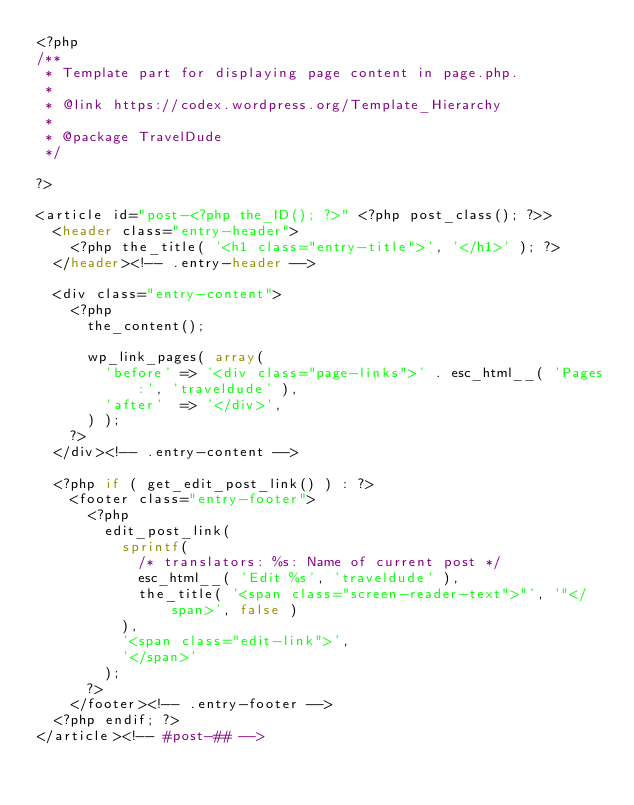<code> <loc_0><loc_0><loc_500><loc_500><_PHP_><?php
/**
 * Template part for displaying page content in page.php.
 *
 * @link https://codex.wordpress.org/Template_Hierarchy
 *
 * @package TravelDude
 */

?>

<article id="post-<?php the_ID(); ?>" <?php post_class(); ?>>
	<header class="entry-header">
		<?php the_title( '<h1 class="entry-title">', '</h1>' ); ?>
	</header><!-- .entry-header -->

	<div class="entry-content">
		<?php
			the_content();

			wp_link_pages( array(
				'before' => '<div class="page-links">' . esc_html__( 'Pages:', 'traveldude' ),
				'after'  => '</div>',
			) );
		?>
	</div><!-- .entry-content -->

	<?php if ( get_edit_post_link() ) : ?>
		<footer class="entry-footer">
			<?php
				edit_post_link(
					sprintf(
						/* translators: %s: Name of current post */
						esc_html__( 'Edit %s', 'traveldude' ),
						the_title( '<span class="screen-reader-text">"', '"</span>', false )
					),
					'<span class="edit-link">',
					'</span>'
				);
			?>
		</footer><!-- .entry-footer -->
	<?php endif; ?>
</article><!-- #post-## -->
</code> 